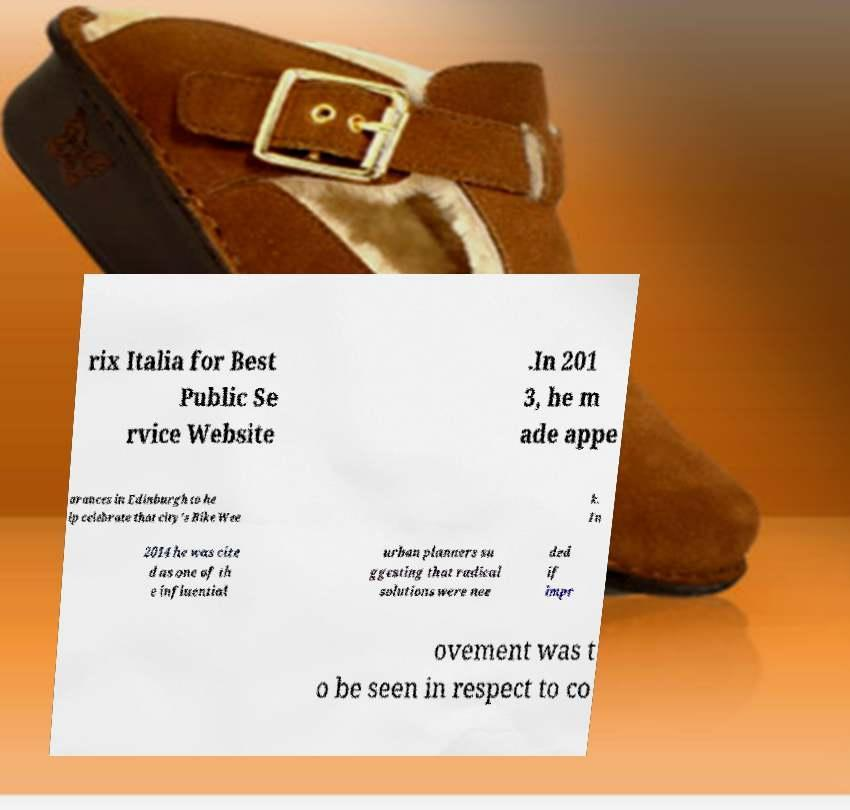Can you read and provide the text displayed in the image?This photo seems to have some interesting text. Can you extract and type it out for me? rix Italia for Best Public Se rvice Website .In 201 3, he m ade appe arances in Edinburgh to he lp celebrate that city's Bike Wee k. In 2014 he was cite d as one of th e influential urban planners su ggesting that radical solutions were nee ded if impr ovement was t o be seen in respect to co 